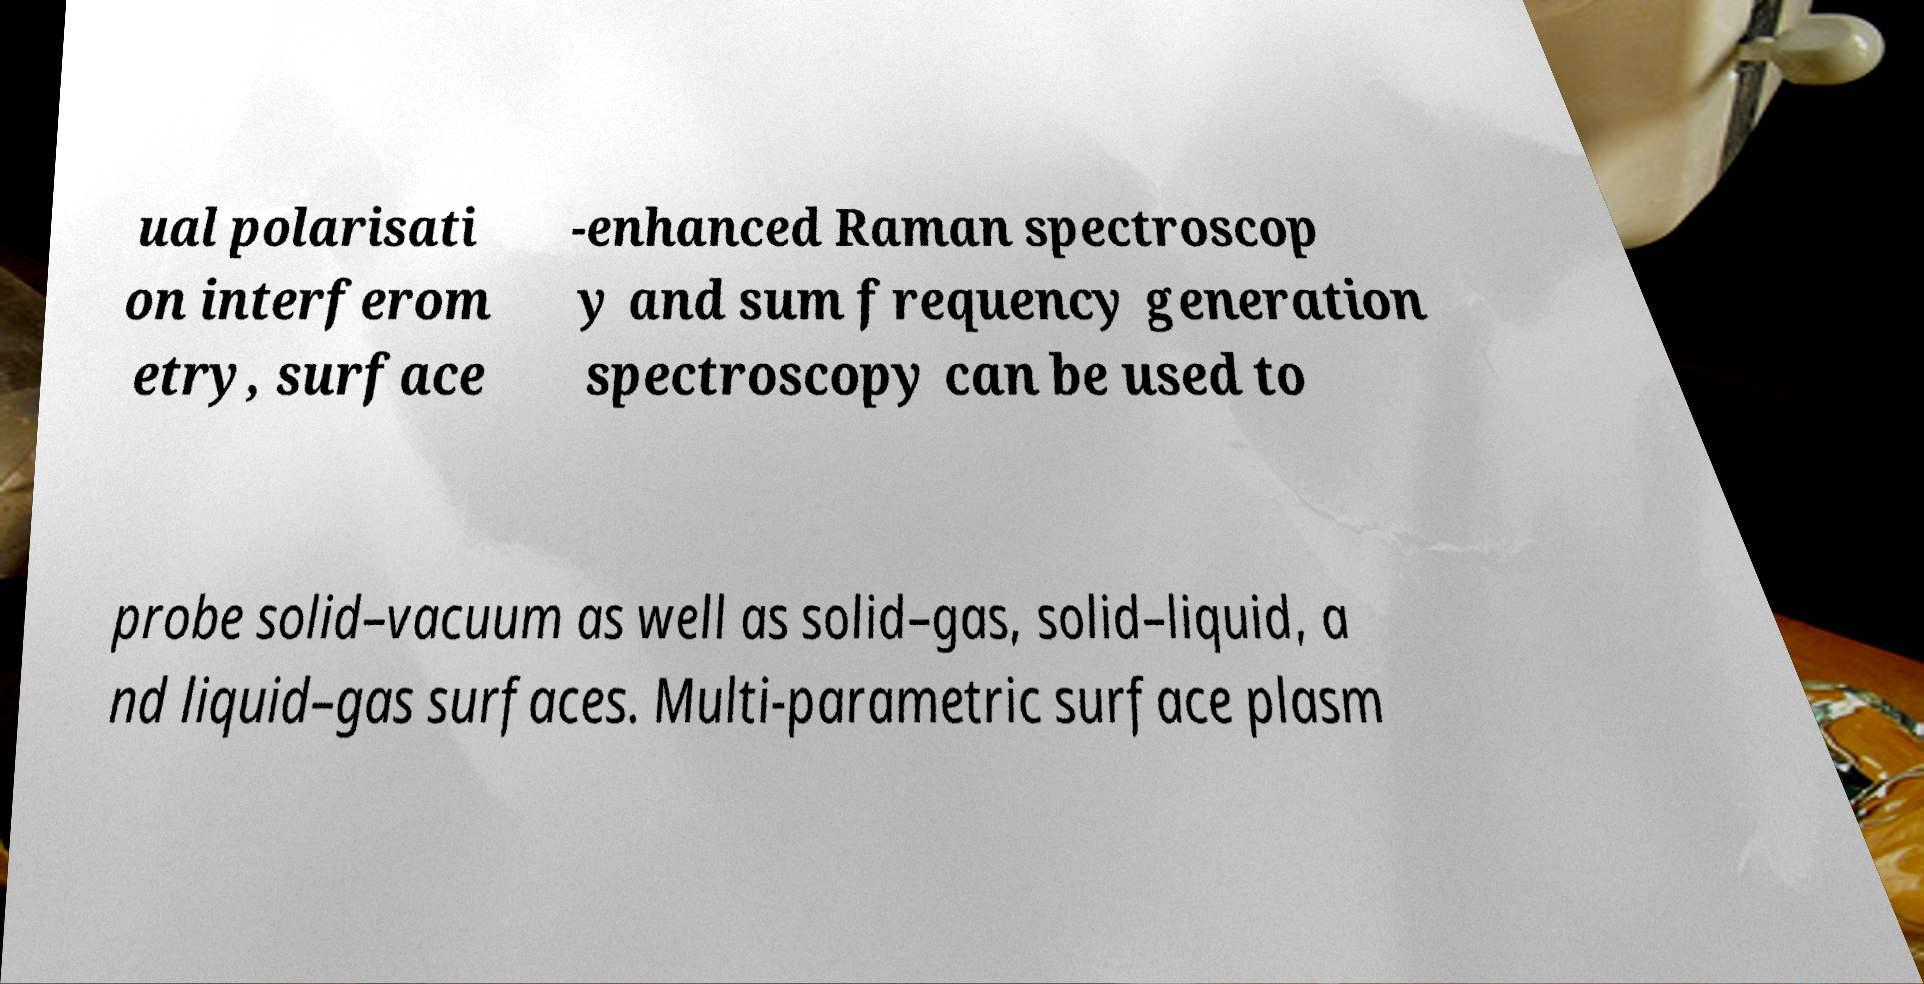There's text embedded in this image that I need extracted. Can you transcribe it verbatim? ual polarisati on interferom etry, surface -enhanced Raman spectroscop y and sum frequency generation spectroscopy can be used to probe solid–vacuum as well as solid–gas, solid–liquid, a nd liquid–gas surfaces. Multi-parametric surface plasm 